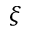<formula> <loc_0><loc_0><loc_500><loc_500>\xi</formula> 